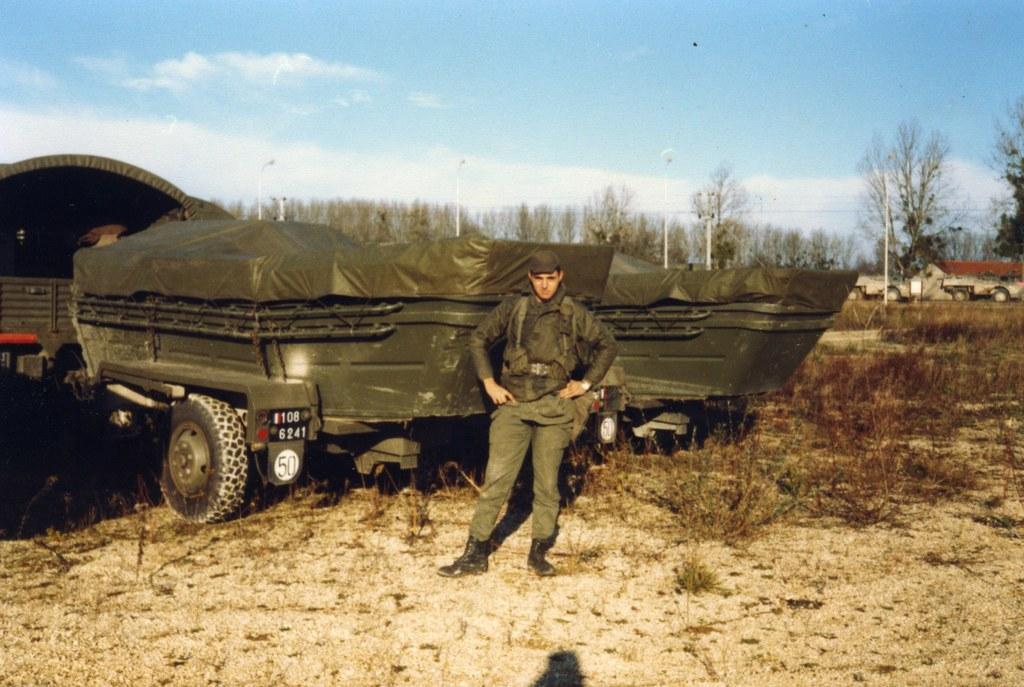Can you describe this image briefly? In this image we can see a person standing on the ground, there are some vehicles, trees, poles, lights, grass and a building, in the background, we can see the sky with clouds. 